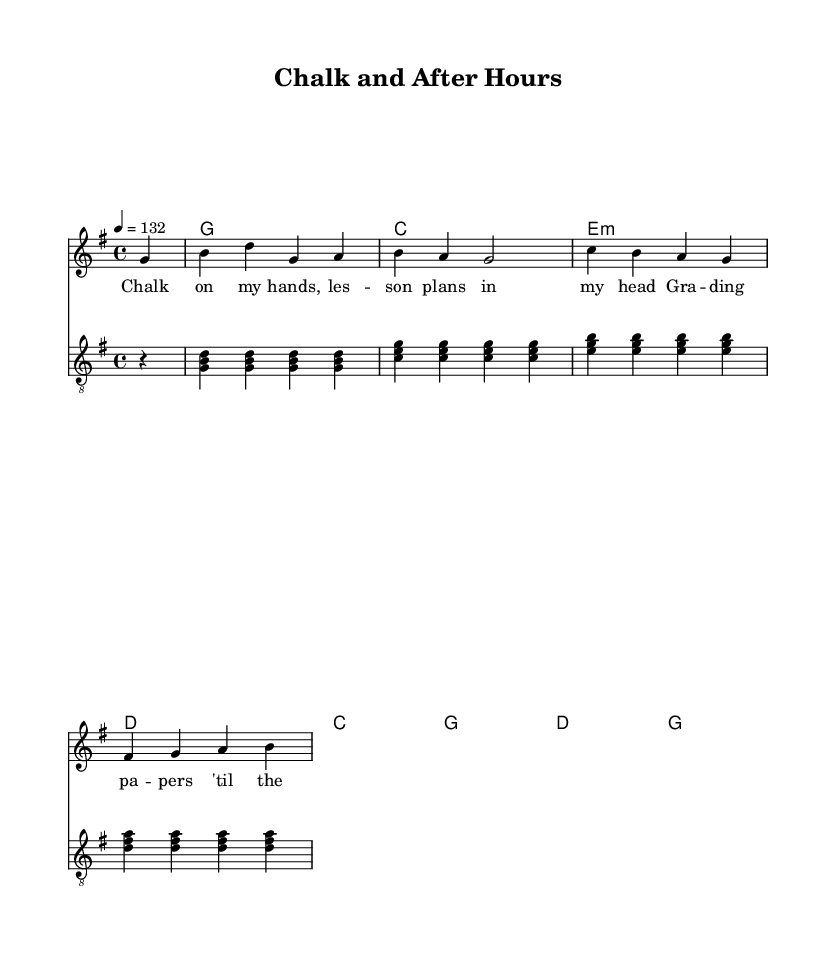What is the key signature of this music? The key signature shown at the beginning of the sheet music indicates that there are no sharps or flats, which corresponds to G major.
Answer: G major What is the time signature of this music? The time signature is displayed at the beginning and is noted as 4/4, which means there are four beats per measure.
Answer: 4/4 What is the tempo marking for this music? The tempo marking states "4 = 132," indicating that the quarter note gets a beat and the piece should be played at a speed of 132 beats per minute.
Answer: 132 How many measures are in the melody section? By counting the number of vertical lines that signify the end of each measure in the melody section, we find there are six measures total.
Answer: 6 Which chord accompanies the first measure of the guitar part? The first chord is indicated in the chord names section and corresponds to the G major chord, which consists of the notes G, B, and D.
Answer: G What lyrical theme is present in the chorus? The chorus emphasizes the idea of balance between work (chalk) and personal life after hours. This reflects the struggle common among educators.
Answer: Balancing act What is the significance of the lyrics: "Chalk on my hands"? This phrase conveys the connection to teaching and the physicality of preparing lessons, suggesting the hard work and dedication of being an educator.
Answer: Connection to teaching 